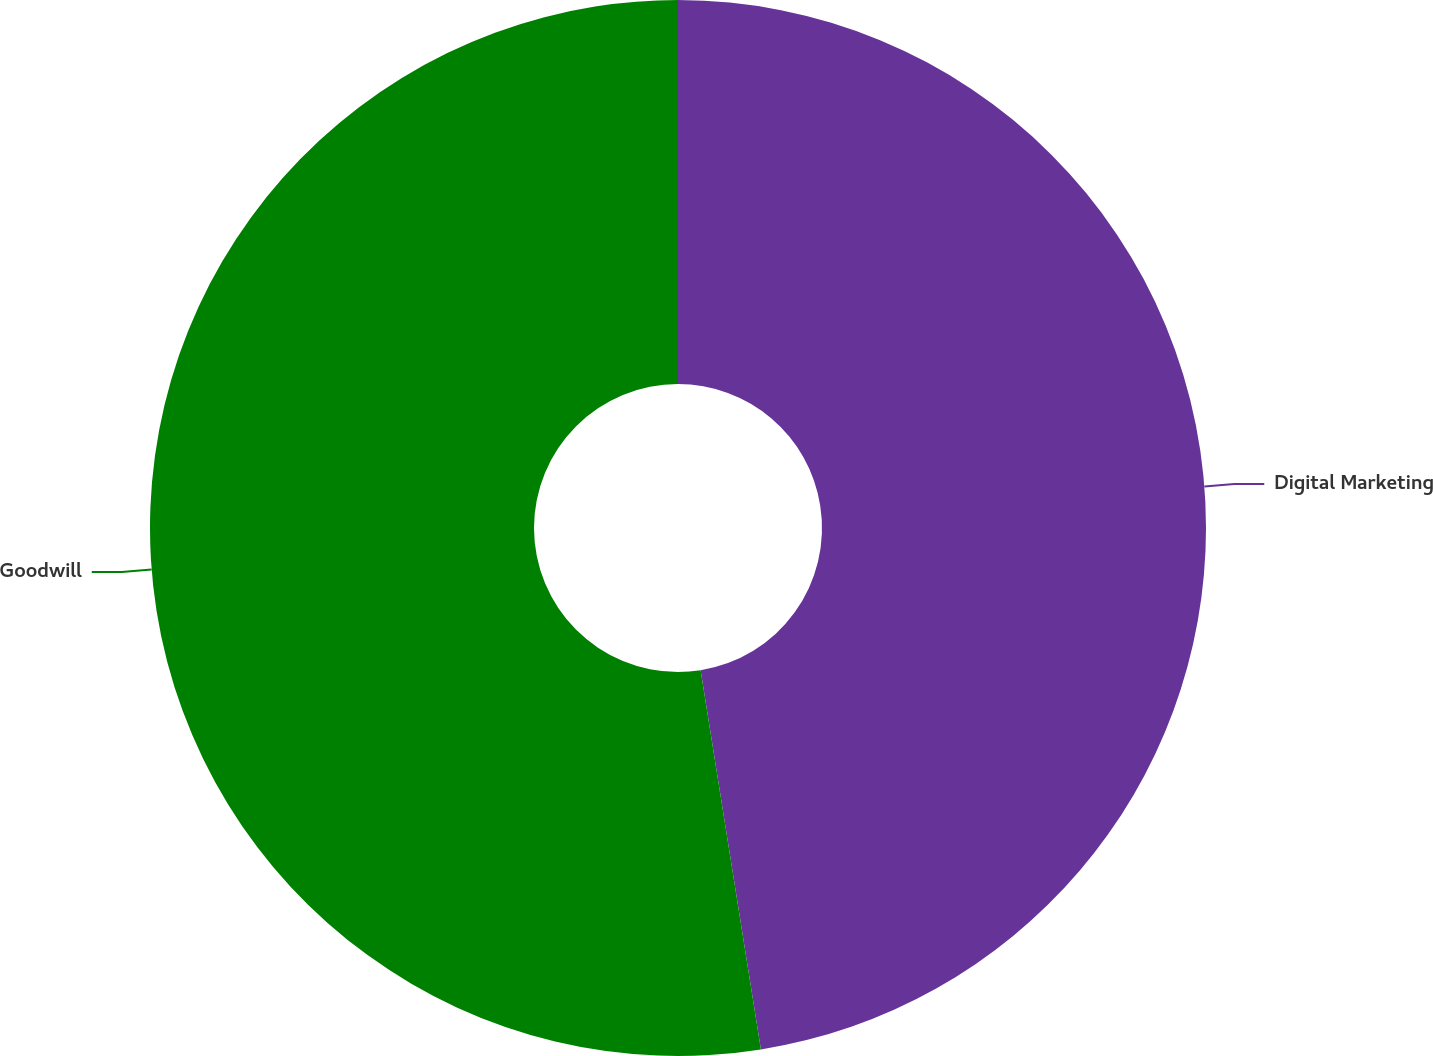Convert chart to OTSL. <chart><loc_0><loc_0><loc_500><loc_500><pie_chart><fcel>Digital Marketing<fcel>Goodwill<nl><fcel>47.49%<fcel>52.51%<nl></chart> 